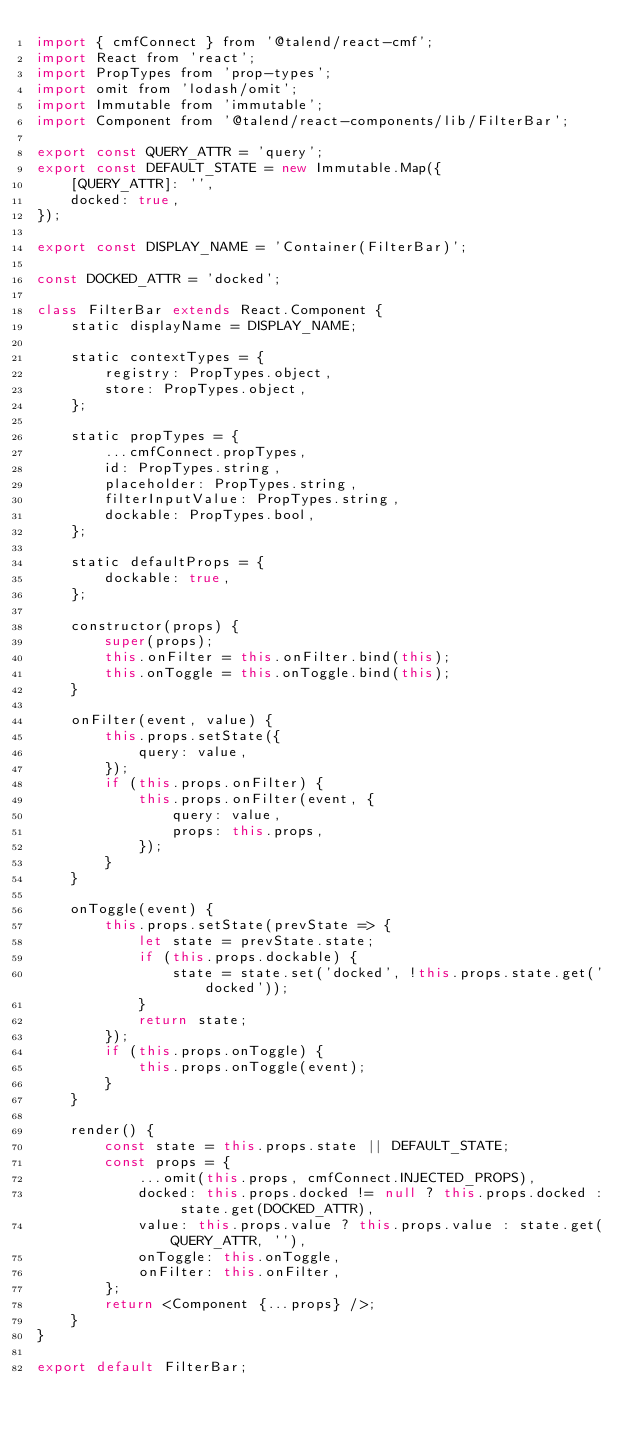Convert code to text. <code><loc_0><loc_0><loc_500><loc_500><_JavaScript_>import { cmfConnect } from '@talend/react-cmf';
import React from 'react';
import PropTypes from 'prop-types';
import omit from 'lodash/omit';
import Immutable from 'immutable';
import Component from '@talend/react-components/lib/FilterBar';

export const QUERY_ATTR = 'query';
export const DEFAULT_STATE = new Immutable.Map({
	[QUERY_ATTR]: '',
	docked: true,
});

export const DISPLAY_NAME = 'Container(FilterBar)';

const DOCKED_ATTR = 'docked';

class FilterBar extends React.Component {
	static displayName = DISPLAY_NAME;

	static contextTypes = {
		registry: PropTypes.object,
		store: PropTypes.object,
	};

	static propTypes = {
		...cmfConnect.propTypes,
		id: PropTypes.string,
		placeholder: PropTypes.string,
		filterInputValue: PropTypes.string,
		dockable: PropTypes.bool,
	};

	static defaultProps = {
		dockable: true,
	};

	constructor(props) {
		super(props);
		this.onFilter = this.onFilter.bind(this);
		this.onToggle = this.onToggle.bind(this);
	}

	onFilter(event, value) {
		this.props.setState({
			query: value,
		});
		if (this.props.onFilter) {
			this.props.onFilter(event, {
				query: value,
				props: this.props,
			});
		}
	}

	onToggle(event) {
		this.props.setState(prevState => {
			let state = prevState.state;
			if (this.props.dockable) {
				state = state.set('docked', !this.props.state.get('docked'));
			}
			return state;
		});
		if (this.props.onToggle) {
			this.props.onToggle(event);
		}
	}

	render() {
		const state = this.props.state || DEFAULT_STATE;
		const props = {
			...omit(this.props, cmfConnect.INJECTED_PROPS),
			docked: this.props.docked != null ? this.props.docked : state.get(DOCKED_ATTR),
			value: this.props.value ? this.props.value : state.get(QUERY_ATTR, ''),
			onToggle: this.onToggle,
			onFilter: this.onFilter,
		};
		return <Component {...props} />;
	}
}

export default FilterBar;
</code> 